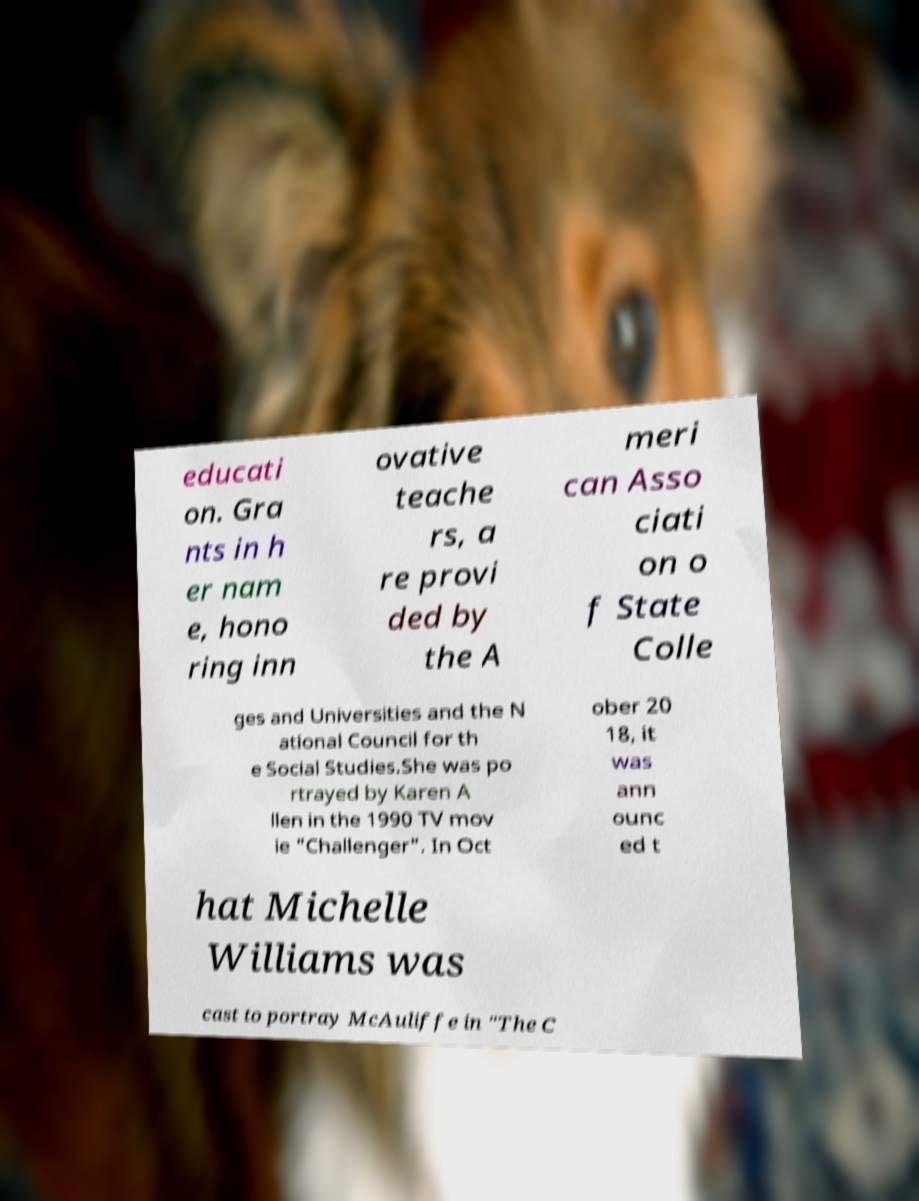Can you accurately transcribe the text from the provided image for me? educati on. Gra nts in h er nam e, hono ring inn ovative teache rs, a re provi ded by the A meri can Asso ciati on o f State Colle ges and Universities and the N ational Council for th e Social Studies.She was po rtrayed by Karen A llen in the 1990 TV mov ie "Challenger". In Oct ober 20 18, it was ann ounc ed t hat Michelle Williams was cast to portray McAuliffe in "The C 